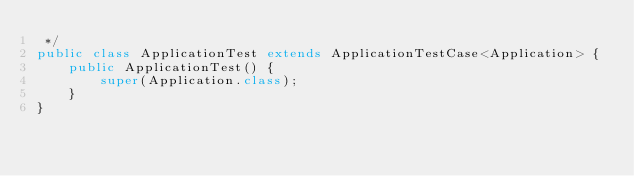Convert code to text. <code><loc_0><loc_0><loc_500><loc_500><_Java_> */
public class ApplicationTest extends ApplicationTestCase<Application> {
    public ApplicationTest() {
        super(Application.class);
    }
}</code> 